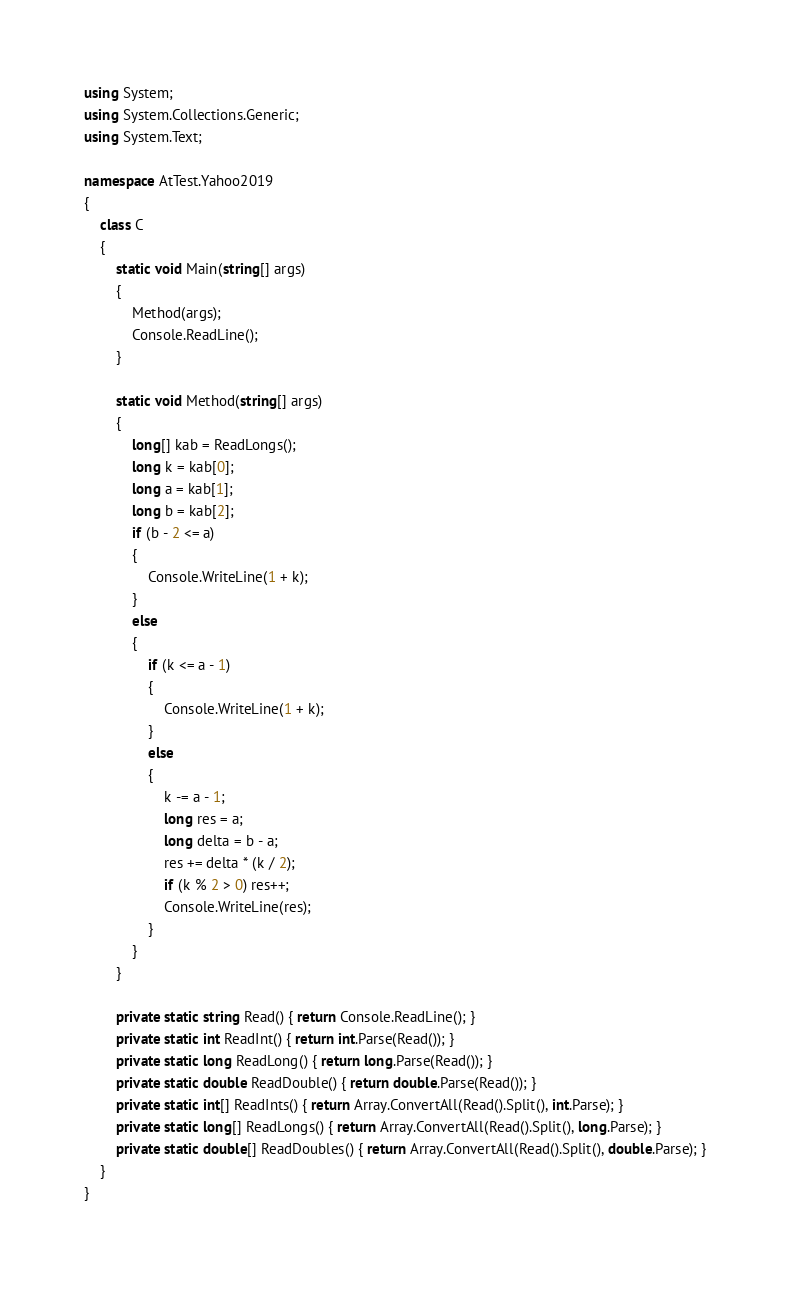Convert code to text. <code><loc_0><loc_0><loc_500><loc_500><_C#_>using System;
using System.Collections.Generic;
using System.Text;

namespace AtTest.Yahoo2019
{
    class C
    {
        static void Main(string[] args)
        {
            Method(args);
            Console.ReadLine();
        }

        static void Method(string[] args)
        {
            long[] kab = ReadLongs();
            long k = kab[0];
            long a = kab[1];
            long b = kab[2];
            if (b - 2 <= a)
            {
                Console.WriteLine(1 + k);
            }
            else
            {
                if (k <= a - 1)
                {
                    Console.WriteLine(1 + k);
                }
                else
                {
                    k -= a - 1;
                    long res = a;
                    long delta = b - a;
                    res += delta * (k / 2);
                    if (k % 2 > 0) res++;
                    Console.WriteLine(res);
                }
            }
        }

        private static string Read() { return Console.ReadLine(); }
        private static int ReadInt() { return int.Parse(Read()); }
        private static long ReadLong() { return long.Parse(Read()); }
        private static double ReadDouble() { return double.Parse(Read()); }
        private static int[] ReadInts() { return Array.ConvertAll(Read().Split(), int.Parse); }
        private static long[] ReadLongs() { return Array.ConvertAll(Read().Split(), long.Parse); }
        private static double[] ReadDoubles() { return Array.ConvertAll(Read().Split(), double.Parse); }
    }
}
</code> 